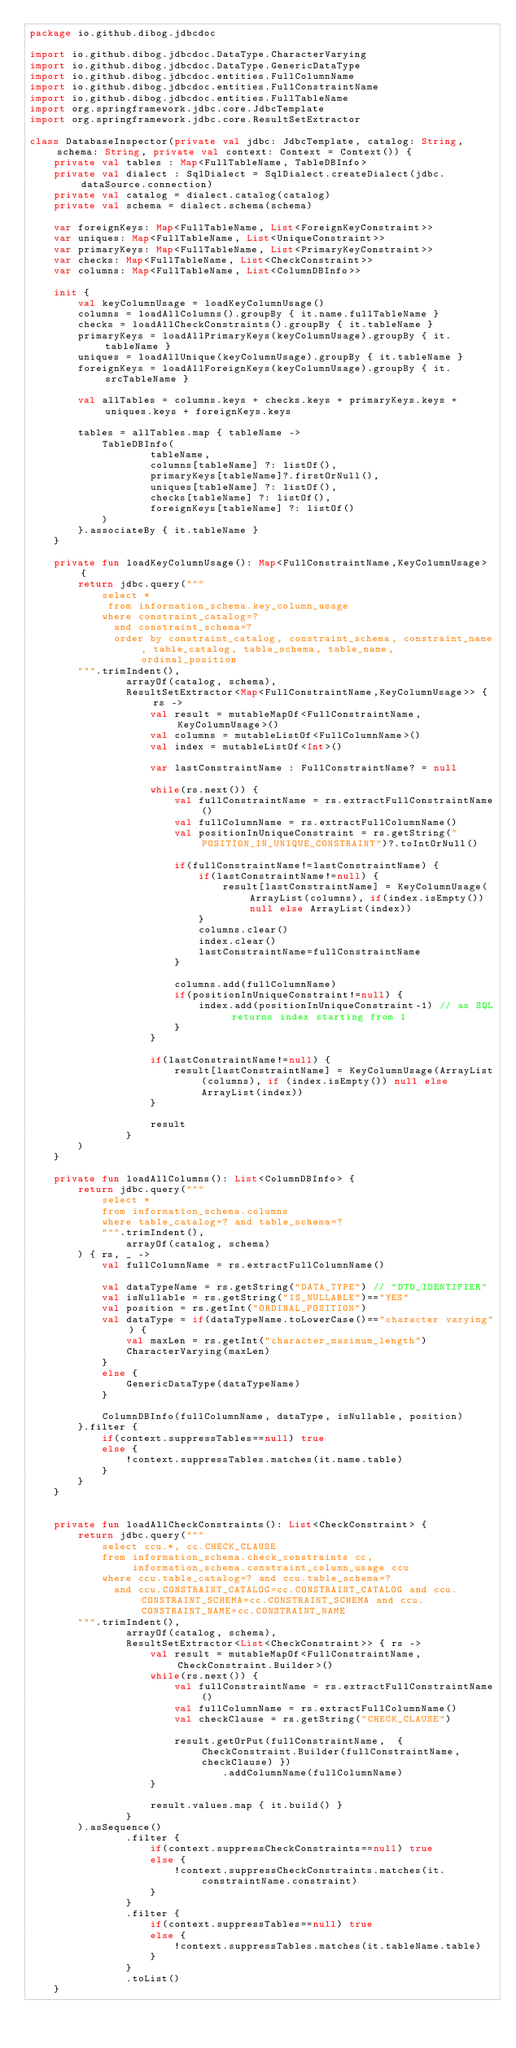Convert code to text. <code><loc_0><loc_0><loc_500><loc_500><_Kotlin_>package io.github.dibog.jdbcdoc

import io.github.dibog.jdbcdoc.DataType.CharacterVarying
import io.github.dibog.jdbcdoc.DataType.GenericDataType
import io.github.dibog.jdbcdoc.entities.FullColumnName
import io.github.dibog.jdbcdoc.entities.FullConstraintName
import io.github.dibog.jdbcdoc.entities.FullTableName
import org.springframework.jdbc.core.JdbcTemplate
import org.springframework.jdbc.core.ResultSetExtractor

class DatabaseInspector(private val jdbc: JdbcTemplate, catalog: String, schema: String, private val context: Context = Context()) {
    private val tables : Map<FullTableName, TableDBInfo>
    private val dialect : SqlDialect = SqlDialect.createDialect(jdbc.dataSource.connection)
    private val catalog = dialect.catalog(catalog)
    private val schema = dialect.schema(schema)

    var foreignKeys: Map<FullTableName, List<ForeignKeyConstraint>>
    var uniques: Map<FullTableName, List<UniqueConstraint>>
    var primaryKeys: Map<FullTableName, List<PrimaryKeyConstraint>>
    var checks: Map<FullTableName, List<CheckConstraint>>
    var columns: Map<FullTableName, List<ColumnDBInfo>>

    init {
        val keyColumnUsage = loadKeyColumnUsage()
        columns = loadAllColumns().groupBy { it.name.fullTableName }
        checks = loadAllCheckConstraints().groupBy { it.tableName }
        primaryKeys = loadAllPrimaryKeys(keyColumnUsage).groupBy { it.tableName }
        uniques = loadAllUnique(keyColumnUsage).groupBy { it.tableName }
        foreignKeys = loadAllForeignKeys(keyColumnUsage).groupBy { it.srcTableName }

        val allTables = columns.keys + checks.keys + primaryKeys.keys + uniques.keys + foreignKeys.keys

        tables = allTables.map { tableName ->
            TableDBInfo(
                    tableName,
                    columns[tableName] ?: listOf(),
                    primaryKeys[tableName]?.firstOrNull(),
                    uniques[tableName] ?: listOf(),
                    checks[tableName] ?: listOf(),
                    foreignKeys[tableName] ?: listOf()
            )
        }.associateBy { it.tableName }
    }

    private fun loadKeyColumnUsage(): Map<FullConstraintName,KeyColumnUsage> {
        return jdbc.query("""
            select * 
             from information_schema.key_column_usage
            where constraint_catalog=?
              and constraint_schema=?
              order by constraint_catalog, constraint_schema, constraint_name, table_catalog, table_schema, table_name, ordinal_position
        """.trimIndent(),
                arrayOf(catalog, schema),
                ResultSetExtractor<Map<FullConstraintName,KeyColumnUsage>> { rs ->
                    val result = mutableMapOf<FullConstraintName, KeyColumnUsage>()
                    val columns = mutableListOf<FullColumnName>()
                    val index = mutableListOf<Int>()

                    var lastConstraintName : FullConstraintName? = null

                    while(rs.next()) {
                        val fullConstraintName = rs.extractFullConstraintName()
                        val fullColumnName = rs.extractFullColumnName()
                        val positionInUniqueConstraint = rs.getString("POSITION_IN_UNIQUE_CONSTRAINT")?.toIntOrNull()

                        if(fullConstraintName!=lastConstraintName) {
                            if(lastConstraintName!=null) {
                                result[lastConstraintName] = KeyColumnUsage(ArrayList(columns), if(index.isEmpty()) null else ArrayList(index))
                            }
                            columns.clear()
                            index.clear()
                            lastConstraintName=fullConstraintName
                        }

                        columns.add(fullColumnName)
                        if(positionInUniqueConstraint!=null) {
                            index.add(positionInUniqueConstraint-1) // as SQL returns index starting from 1
                        }
                    }

                    if(lastConstraintName!=null) {
                        result[lastConstraintName] = KeyColumnUsage(ArrayList(columns), if (index.isEmpty()) null else ArrayList(index))
                    }

                    result
                }
        )
    }

    private fun loadAllColumns(): List<ColumnDBInfo> {
        return jdbc.query("""
            select *
            from information_schema.columns
            where table_catalog=? and table_schema=?
            """.trimIndent(),
                arrayOf(catalog, schema)
        ) { rs, _ ->
            val fullColumnName = rs.extractFullColumnName()

            val dataTypeName = rs.getString("DATA_TYPE") // "DTD_IDENTIFIER"
            val isNullable = rs.getString("IS_NULLABLE")=="YES"
            val position = rs.getInt("ORDINAL_POSITION")
            val dataType = if(dataTypeName.toLowerCase()=="character varying") {
                val maxLen = rs.getInt("character_maximum_length")
                CharacterVarying(maxLen)
            }
            else {
                GenericDataType(dataTypeName)
            }

            ColumnDBInfo(fullColumnName, dataType, isNullable, position)
        }.filter {
            if(context.suppressTables==null) true
            else {
                !context.suppressTables.matches(it.name.table)
            }
        }
    }


    private fun loadAllCheckConstraints(): List<CheckConstraint> {
        return jdbc.query("""
            select ccu.*, cc.CHECK_CLAUSE
            from information_schema.check_constraints cc, 
                 information_schema.constraint_column_usage ccu
            where ccu.table_catalog=? and ccu.table_schema=?
              and ccu.CONSTRAINT_CATALOG=cc.CONSTRAINT_CATALOG and ccu.CONSTRAINT_SCHEMA=cc.CONSTRAINT_SCHEMA and ccu.CONSTRAINT_NAME=cc.CONSTRAINT_NAME
        """.trimIndent(),
                arrayOf(catalog, schema),
                ResultSetExtractor<List<CheckConstraint>> { rs ->
                    val result = mutableMapOf<FullConstraintName, CheckConstraint.Builder>()
                    while(rs.next()) {
                        val fullConstraintName = rs.extractFullConstraintName()
                        val fullColumnName = rs.extractFullColumnName()
                        val checkClause = rs.getString("CHECK_CLAUSE")

                        result.getOrPut(fullConstraintName,  { CheckConstraint.Builder(fullConstraintName, checkClause) })
                                .addColumnName(fullColumnName)
                    }

                    result.values.map { it.build() }
                }
        ).asSequence()
                .filter {
                    if(context.suppressCheckConstraints==null) true
                    else {
                        !context.suppressCheckConstraints.matches(it.constraintName.constraint)
                    }
                }
                .filter {
                    if(context.suppressTables==null) true
                    else {
                        !context.suppressTables.matches(it.tableName.table)
                    }
                }
                .toList()
    }
</code> 